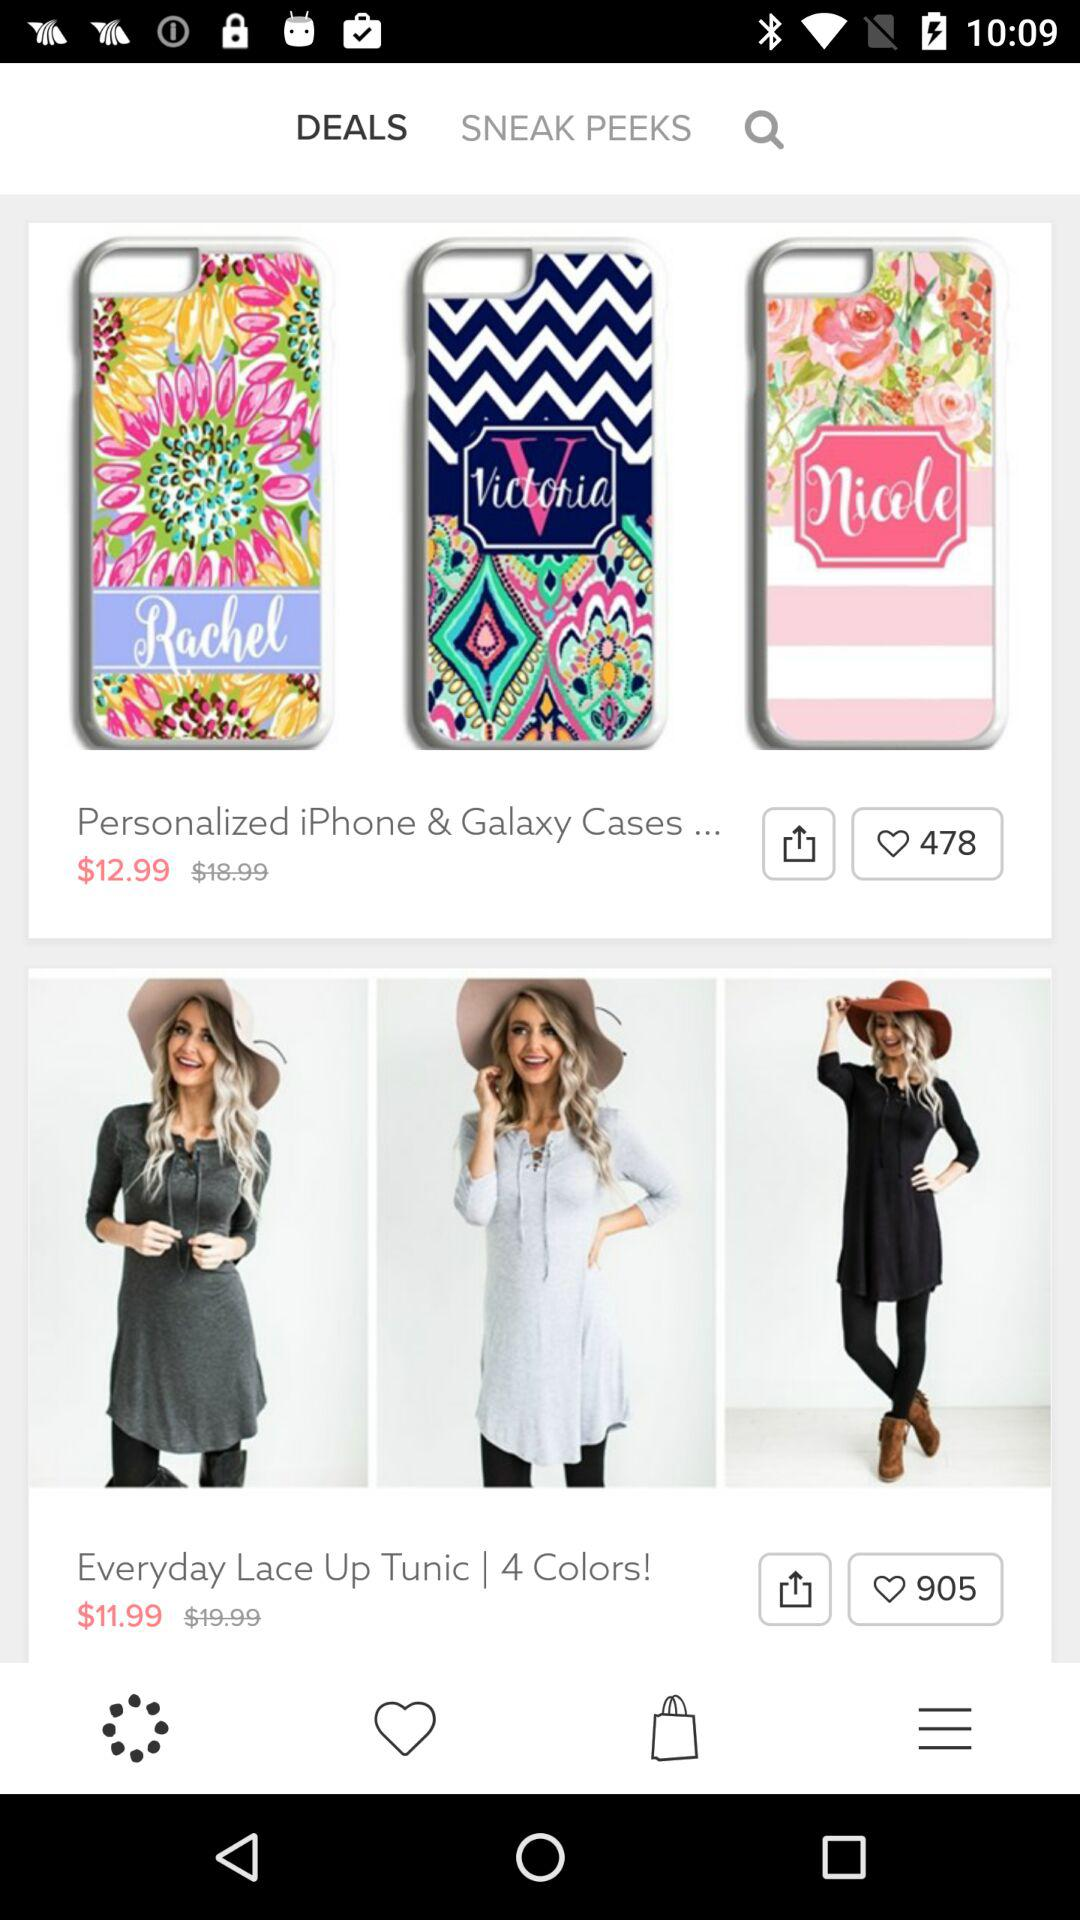What is the discounted price of the "Everyday Lace Up Tunic"? The discounted price is $11.99. 